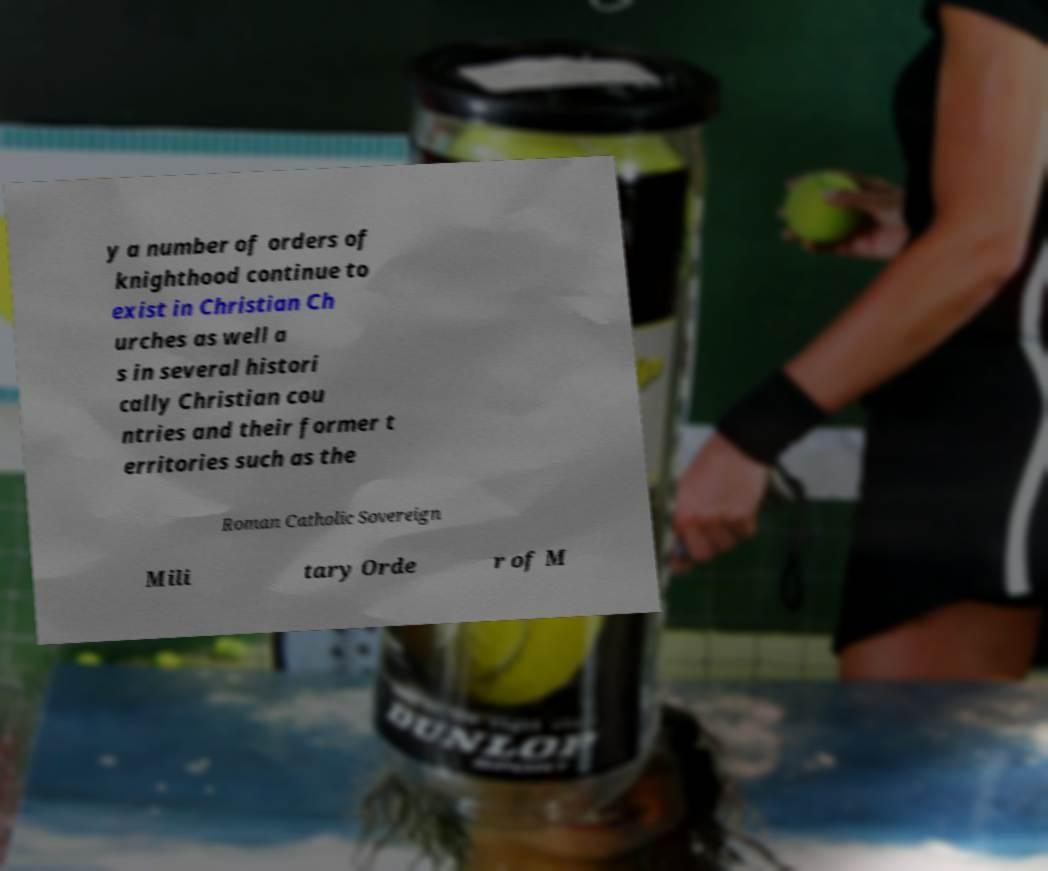Could you assist in decoding the text presented in this image and type it out clearly? y a number of orders of knighthood continue to exist in Christian Ch urches as well a s in several histori cally Christian cou ntries and their former t erritories such as the Roman Catholic Sovereign Mili tary Orde r of M 